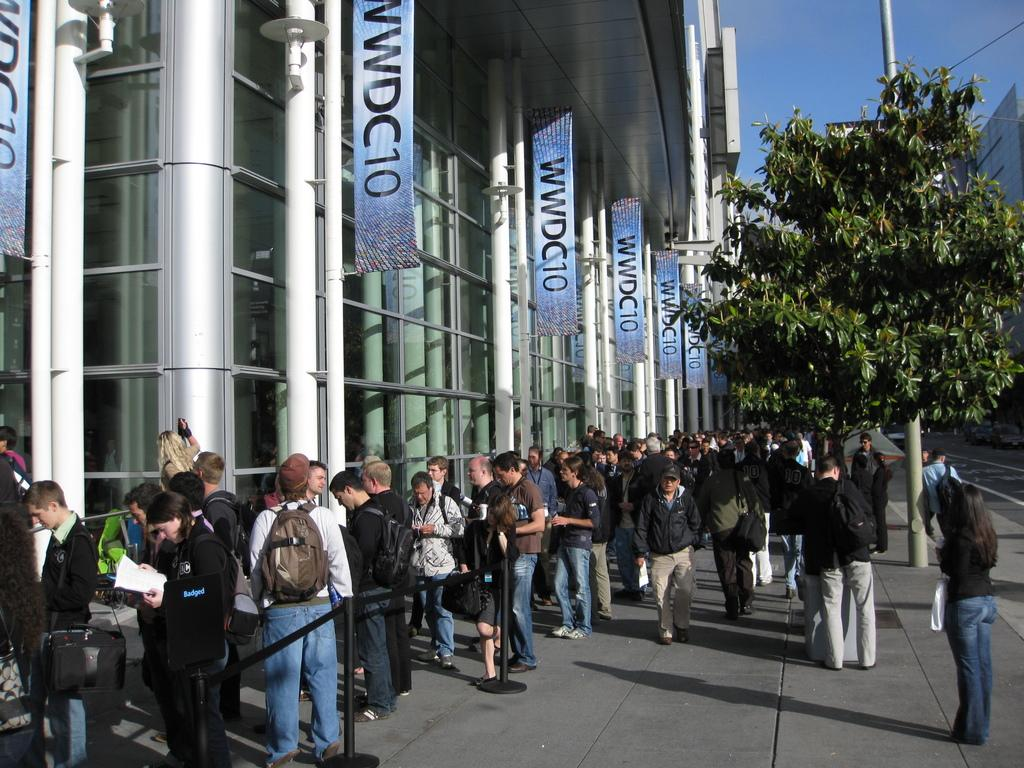<image>
Relay a brief, clear account of the picture shown. A crowd of people standing outside of the WWDC10 convention 